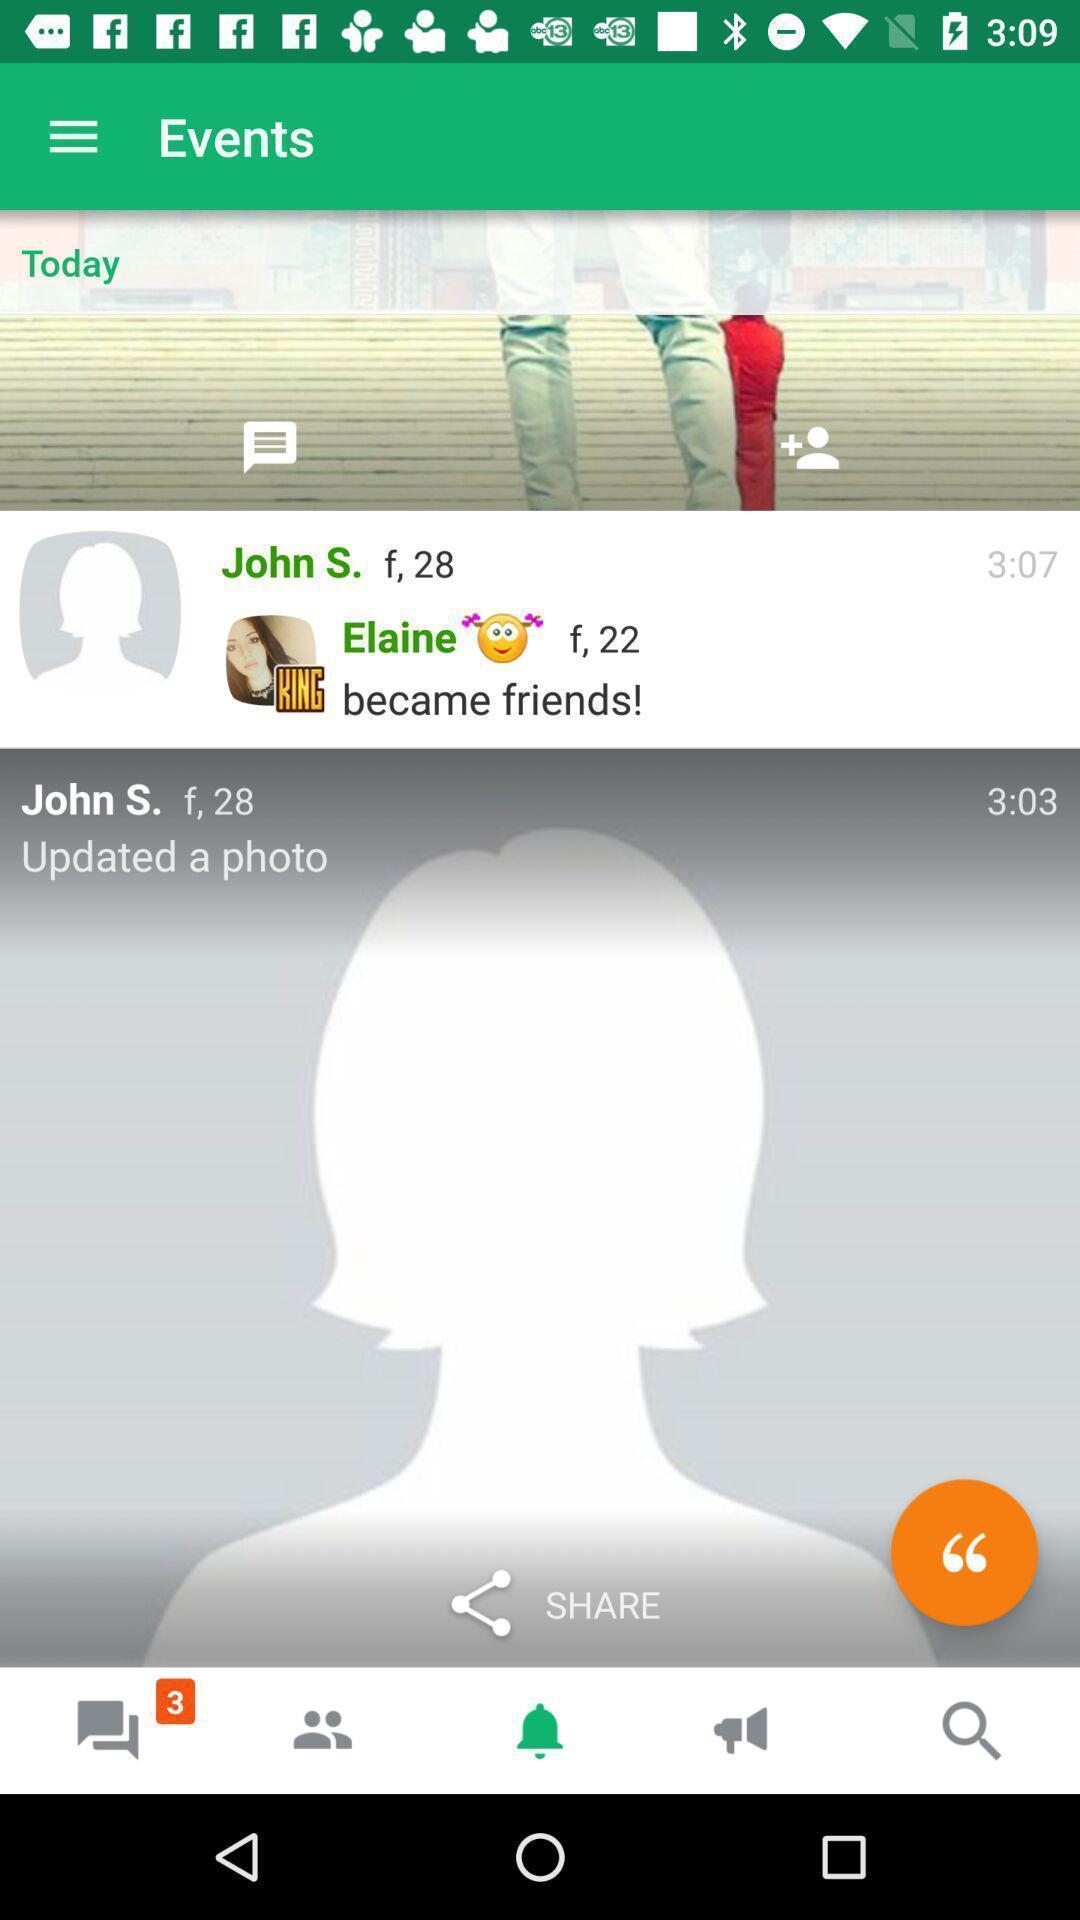Describe the visual elements of this screenshot. Page displaying the events. 